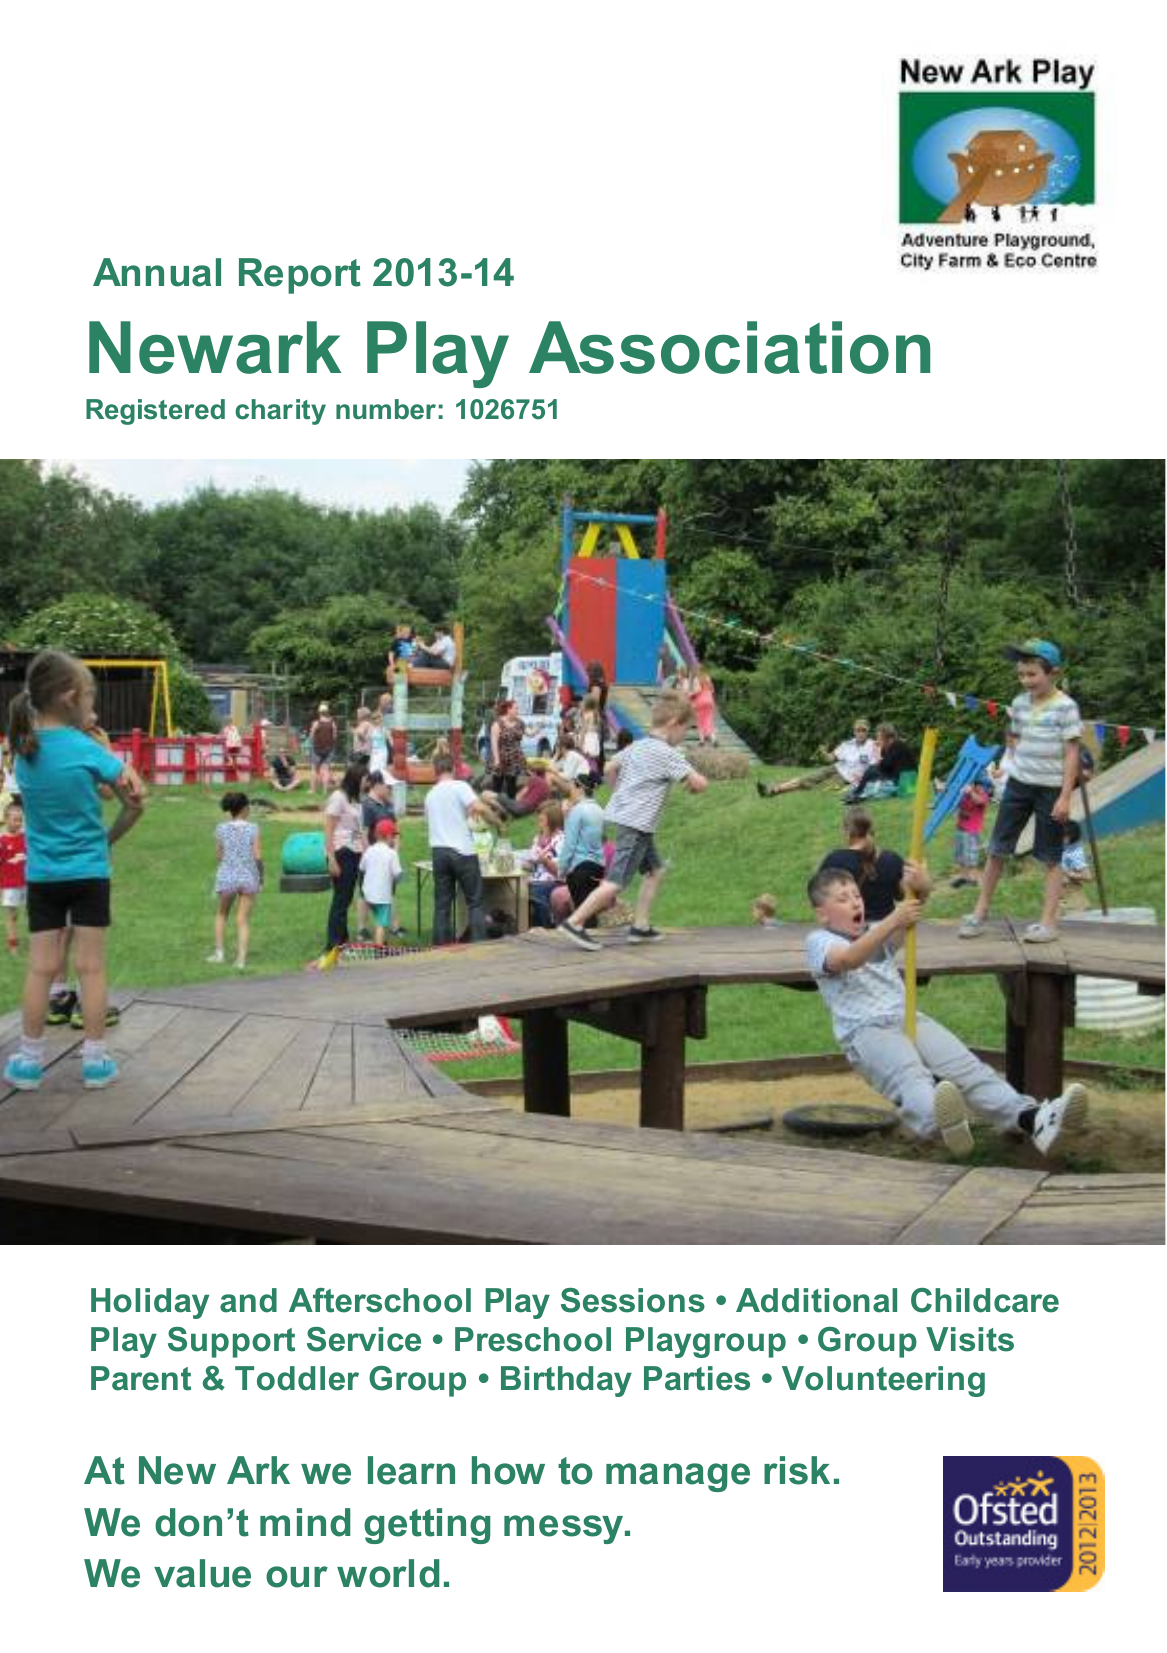What is the value for the income_annually_in_british_pounds?
Answer the question using a single word or phrase. 266187.00 